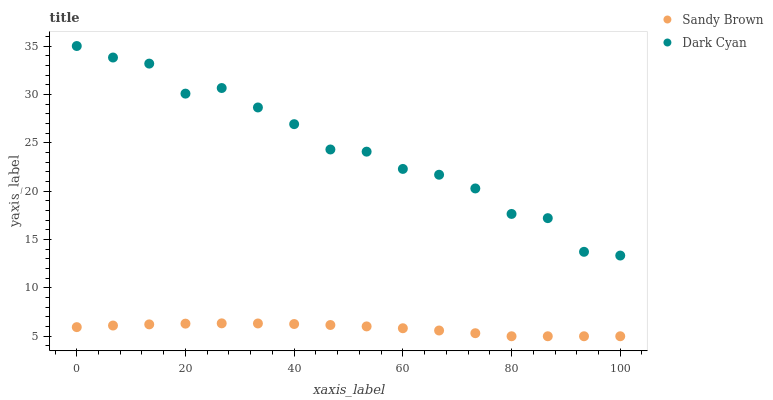Does Sandy Brown have the minimum area under the curve?
Answer yes or no. Yes. Does Dark Cyan have the maximum area under the curve?
Answer yes or no. Yes. Does Sandy Brown have the maximum area under the curve?
Answer yes or no. No. Is Sandy Brown the smoothest?
Answer yes or no. Yes. Is Dark Cyan the roughest?
Answer yes or no. Yes. Is Sandy Brown the roughest?
Answer yes or no. No. Does Sandy Brown have the lowest value?
Answer yes or no. Yes. Does Dark Cyan have the highest value?
Answer yes or no. Yes. Does Sandy Brown have the highest value?
Answer yes or no. No. Is Sandy Brown less than Dark Cyan?
Answer yes or no. Yes. Is Dark Cyan greater than Sandy Brown?
Answer yes or no. Yes. Does Sandy Brown intersect Dark Cyan?
Answer yes or no. No. 